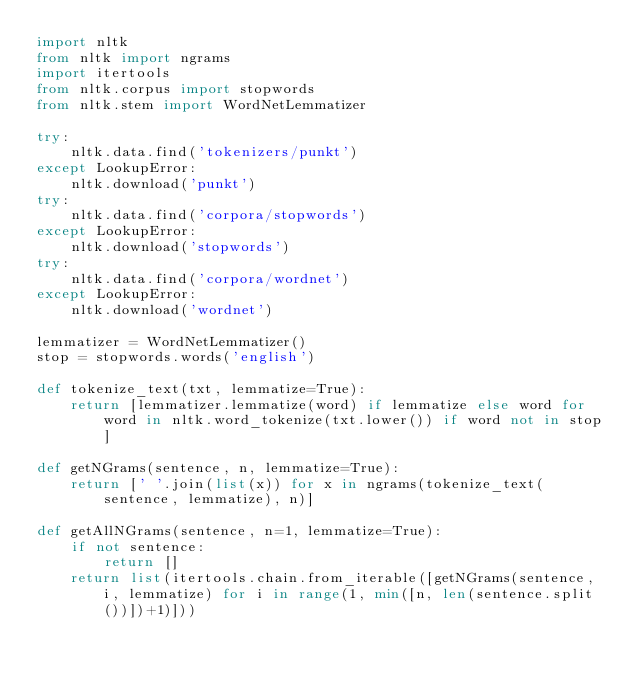Convert code to text. <code><loc_0><loc_0><loc_500><loc_500><_Python_>import nltk
from nltk import ngrams
import itertools
from nltk.corpus import stopwords
from nltk.stem import WordNetLemmatizer

try:
    nltk.data.find('tokenizers/punkt')
except LookupError:
    nltk.download('punkt')
try:
    nltk.data.find('corpora/stopwords')
except LookupError:
    nltk.download('stopwords')
try:
    nltk.data.find('corpora/wordnet')
except LookupError:
    nltk.download('wordnet')

lemmatizer = WordNetLemmatizer()
stop = stopwords.words('english')

def tokenize_text(txt, lemmatize=True):
    return [lemmatizer.lemmatize(word) if lemmatize else word for word in nltk.word_tokenize(txt.lower()) if word not in stop]

def getNGrams(sentence, n, lemmatize=True):
    return [' '.join(list(x)) for x in ngrams(tokenize_text(sentence, lemmatize), n)]

def getAllNGrams(sentence, n=1, lemmatize=True):
    if not sentence:
        return []
    return list(itertools.chain.from_iterable([getNGrams(sentence, i, lemmatize) for i in range(1, min([n, len(sentence.split())])+1)]))</code> 